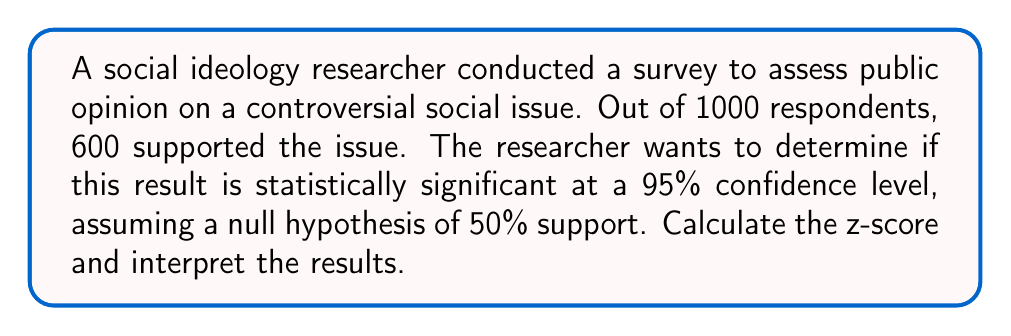Give your solution to this math problem. To determine the statistical significance of the survey results, we need to calculate the z-score and compare it to the critical value for a 95% confidence level.

Step 1: Calculate the sample proportion
$p = \frac{\text{number of supporters}}{\text{total respondents}} = \frac{600}{1000} = 0.6$

Step 2: Determine the null hypothesis proportion
$p_0 = 0.5$ (assumed 50% support)

Step 3: Calculate the standard error
$SE = \sqrt{\frac{p_0(1-p_0)}{n}} = \sqrt{\frac{0.5(1-0.5)}{1000}} = 0.0158$

Step 4: Calculate the z-score
$$z = \frac{p - p_0}{SE} = \frac{0.6 - 0.5}{0.0158} = 6.33$$

Step 5: Determine the critical value
For a 95% confidence level (two-tailed test), the critical value is ±1.96.

Step 6: Interpret the results
Since the calculated z-score (6.33) is greater than the critical value (1.96), we reject the null hypothesis. This means the survey result is statistically significant at the 95% confidence level.

The p-value for this z-score can be calculated, but it would be extremely small (p < 0.0001), further confirming the significance of the result.
Answer: The z-score is 6.33, which is greater than the critical value of 1.96 for a 95% confidence level. Therefore, the survey result is statistically significant, indicating strong evidence that public support for the issue is different from 50%. 